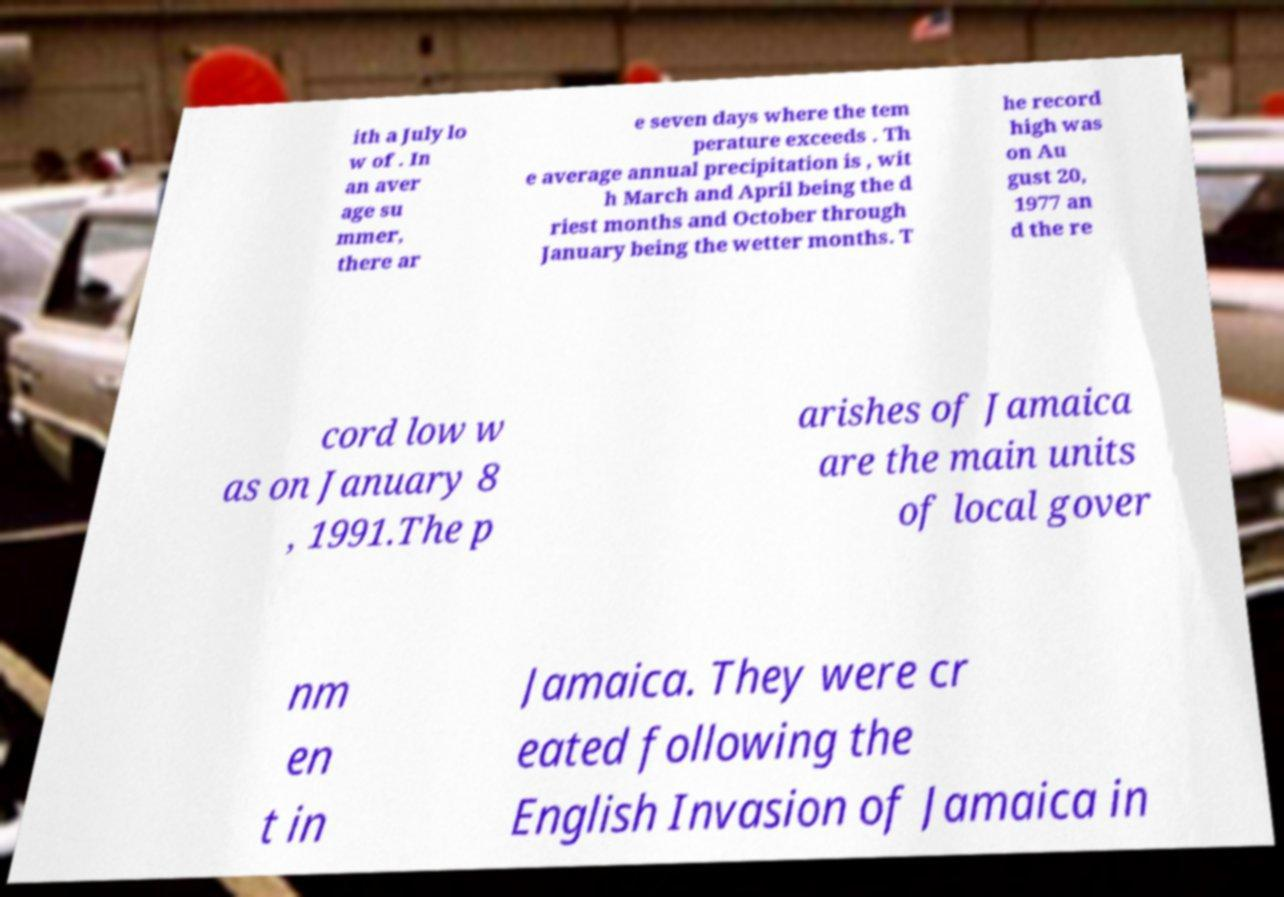Can you accurately transcribe the text from the provided image for me? ith a July lo w of . In an aver age su mmer, there ar e seven days where the tem perature exceeds . Th e average annual precipitation is , wit h March and April being the d riest months and October through January being the wetter months. T he record high was on Au gust 20, 1977 an d the re cord low w as on January 8 , 1991.The p arishes of Jamaica are the main units of local gover nm en t in Jamaica. They were cr eated following the English Invasion of Jamaica in 